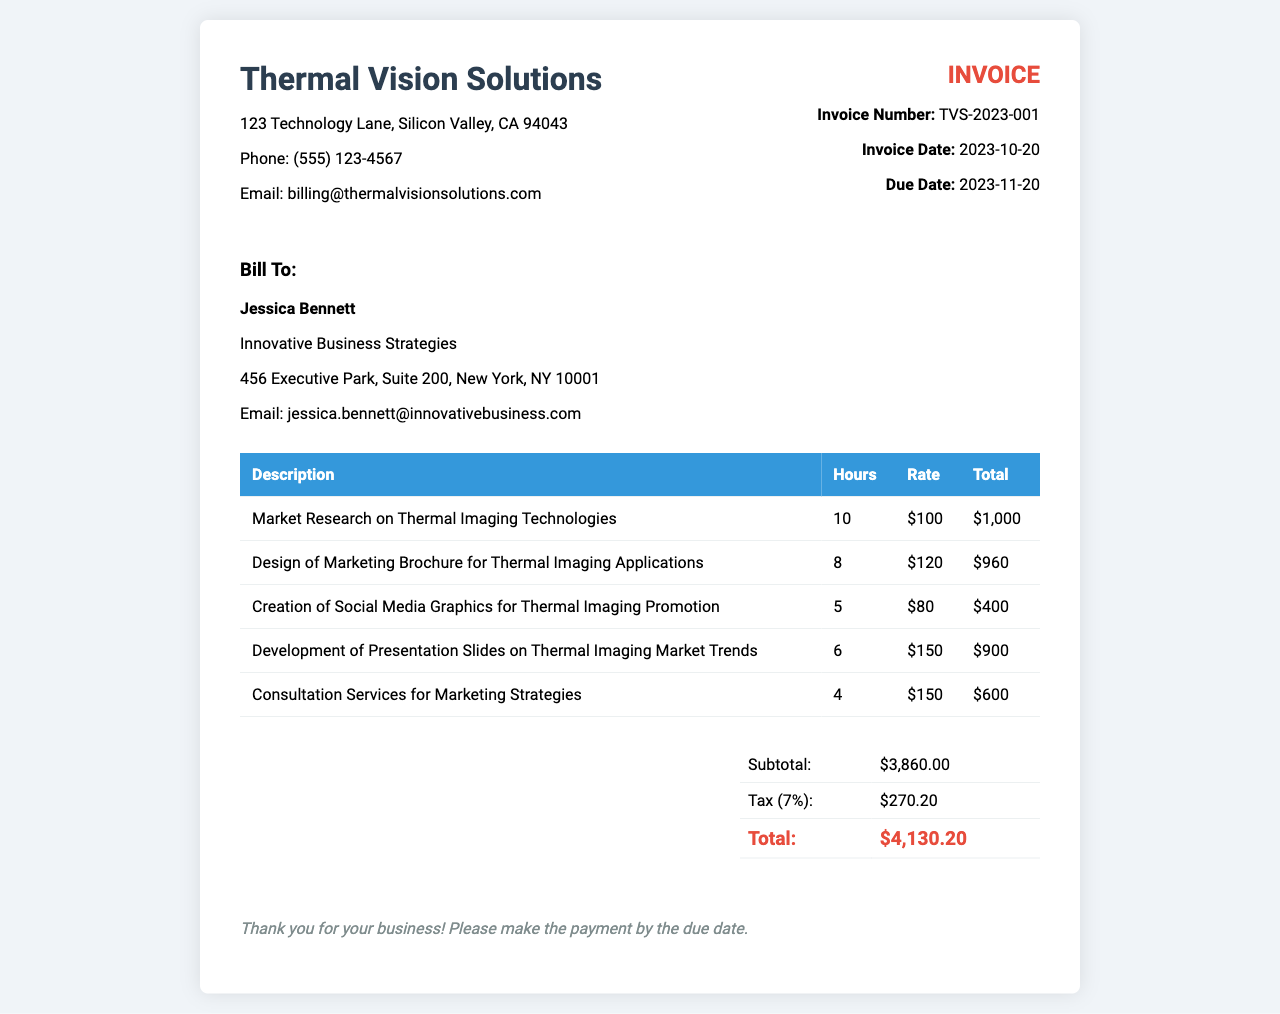What is the invoice number? The invoice number is found in the invoice details section, showcasing the unique identification of the invoice.
Answer: TVS-2023-001 Who is the bill to? The "Bill To" section details the recipient of the invoice, including the name and organization.
Answer: Jessica Bennett What is the due date? The due date is explicitly stated in the invoice details section, indicating the deadline for payment.
Answer: 2023-11-20 What is the subtotal amount? The subtotal is the total before any taxes or additional charges, listed in the total section of the invoice.
Answer: $3,860.00 How much was charged for the market research service? The specific service charge is outlined in the itemized table under the relevant service entry.
Answer: $1,000 What is the tax rate applied in this invoice? The tax rate can be derived from the tax calculation, which is indicated as a percentage of the subtotal.
Answer: 7% What service has the highest cost? By reviewing the itemized service costs, one can determine which service incurred the highest expense.
Answer: Market Research on Thermal Imaging Technologies What is the total amount due? The total amount due is clearly stated after all calculations in the total section of the invoice.
Answer: $4,130.20 What is the email address for billing inquiries? The email address for billing inquiries is provided within the company information section of the invoice.
Answer: billing@thermalvisionsolutions.com 